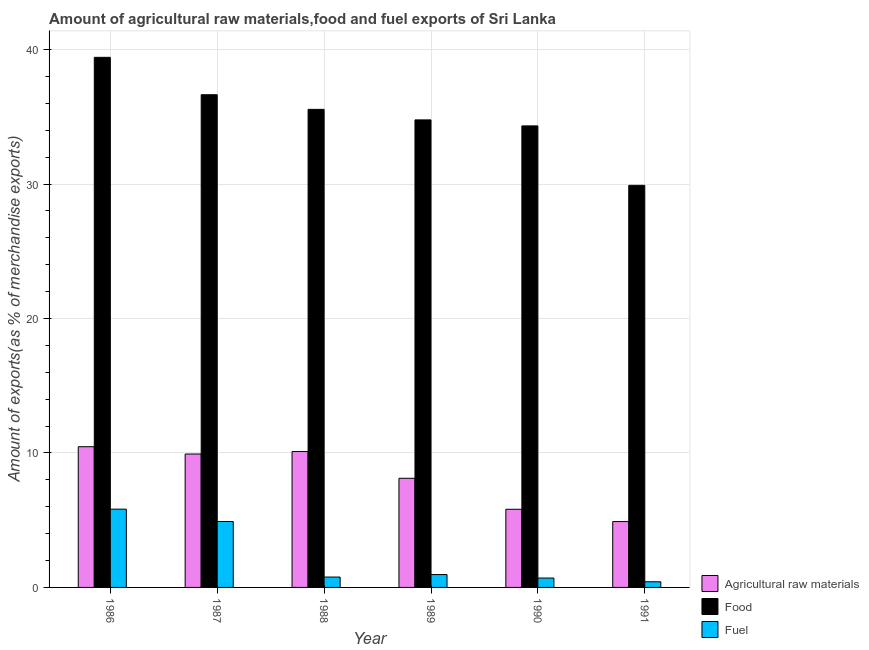Are the number of bars per tick equal to the number of legend labels?
Your answer should be compact. Yes. How many bars are there on the 4th tick from the right?
Provide a short and direct response. 3. What is the percentage of raw materials exports in 1991?
Offer a terse response. 4.9. Across all years, what is the maximum percentage of raw materials exports?
Your response must be concise. 10.47. Across all years, what is the minimum percentage of food exports?
Provide a succinct answer. 29.9. In which year was the percentage of raw materials exports maximum?
Your answer should be compact. 1986. What is the total percentage of food exports in the graph?
Give a very brief answer. 210.63. What is the difference between the percentage of raw materials exports in 1987 and that in 1991?
Your answer should be compact. 5.02. What is the difference between the percentage of food exports in 1988 and the percentage of raw materials exports in 1991?
Provide a short and direct response. 5.65. What is the average percentage of raw materials exports per year?
Make the answer very short. 8.22. In the year 1990, what is the difference between the percentage of fuel exports and percentage of raw materials exports?
Provide a short and direct response. 0. What is the ratio of the percentage of fuel exports in 1990 to that in 1991?
Your response must be concise. 1.66. What is the difference between the highest and the second highest percentage of food exports?
Your answer should be very brief. 2.78. What is the difference between the highest and the lowest percentage of fuel exports?
Provide a succinct answer. 5.4. In how many years, is the percentage of food exports greater than the average percentage of food exports taken over all years?
Ensure brevity in your answer.  3. Is the sum of the percentage of food exports in 1988 and 1991 greater than the maximum percentage of raw materials exports across all years?
Make the answer very short. Yes. What does the 1st bar from the left in 1987 represents?
Your answer should be compact. Agricultural raw materials. What does the 1st bar from the right in 1990 represents?
Ensure brevity in your answer.  Fuel. Are all the bars in the graph horizontal?
Your answer should be very brief. No. How many years are there in the graph?
Give a very brief answer. 6. Are the values on the major ticks of Y-axis written in scientific E-notation?
Your answer should be very brief. No. How are the legend labels stacked?
Offer a terse response. Vertical. What is the title of the graph?
Offer a terse response. Amount of agricultural raw materials,food and fuel exports of Sri Lanka. Does "Travel services" appear as one of the legend labels in the graph?
Keep it short and to the point. No. What is the label or title of the Y-axis?
Ensure brevity in your answer.  Amount of exports(as % of merchandise exports). What is the Amount of exports(as % of merchandise exports) of Agricultural raw materials in 1986?
Keep it short and to the point. 10.47. What is the Amount of exports(as % of merchandise exports) in Food in 1986?
Provide a short and direct response. 39.43. What is the Amount of exports(as % of merchandise exports) of Fuel in 1986?
Give a very brief answer. 5.82. What is the Amount of exports(as % of merchandise exports) of Agricultural raw materials in 1987?
Give a very brief answer. 9.92. What is the Amount of exports(as % of merchandise exports) in Food in 1987?
Your response must be concise. 36.64. What is the Amount of exports(as % of merchandise exports) in Fuel in 1987?
Make the answer very short. 4.9. What is the Amount of exports(as % of merchandise exports) of Agricultural raw materials in 1988?
Your answer should be very brief. 10.11. What is the Amount of exports(as % of merchandise exports) in Food in 1988?
Your response must be concise. 35.56. What is the Amount of exports(as % of merchandise exports) of Fuel in 1988?
Make the answer very short. 0.77. What is the Amount of exports(as % of merchandise exports) of Agricultural raw materials in 1989?
Provide a succinct answer. 8.12. What is the Amount of exports(as % of merchandise exports) in Food in 1989?
Offer a very short reply. 34.77. What is the Amount of exports(as % of merchandise exports) in Fuel in 1989?
Your response must be concise. 0.96. What is the Amount of exports(as % of merchandise exports) of Agricultural raw materials in 1990?
Your answer should be very brief. 5.81. What is the Amount of exports(as % of merchandise exports) in Food in 1990?
Offer a terse response. 34.33. What is the Amount of exports(as % of merchandise exports) in Fuel in 1990?
Your answer should be compact. 0.7. What is the Amount of exports(as % of merchandise exports) in Agricultural raw materials in 1991?
Ensure brevity in your answer.  4.9. What is the Amount of exports(as % of merchandise exports) in Food in 1991?
Your response must be concise. 29.9. What is the Amount of exports(as % of merchandise exports) of Fuel in 1991?
Keep it short and to the point. 0.42. Across all years, what is the maximum Amount of exports(as % of merchandise exports) in Agricultural raw materials?
Keep it short and to the point. 10.47. Across all years, what is the maximum Amount of exports(as % of merchandise exports) of Food?
Provide a short and direct response. 39.43. Across all years, what is the maximum Amount of exports(as % of merchandise exports) of Fuel?
Ensure brevity in your answer.  5.82. Across all years, what is the minimum Amount of exports(as % of merchandise exports) of Agricultural raw materials?
Your answer should be very brief. 4.9. Across all years, what is the minimum Amount of exports(as % of merchandise exports) in Food?
Your response must be concise. 29.9. Across all years, what is the minimum Amount of exports(as % of merchandise exports) of Fuel?
Provide a succinct answer. 0.42. What is the total Amount of exports(as % of merchandise exports) in Agricultural raw materials in the graph?
Provide a succinct answer. 49.32. What is the total Amount of exports(as % of merchandise exports) of Food in the graph?
Your answer should be compact. 210.63. What is the total Amount of exports(as % of merchandise exports) in Fuel in the graph?
Give a very brief answer. 13.57. What is the difference between the Amount of exports(as % of merchandise exports) in Agricultural raw materials in 1986 and that in 1987?
Provide a succinct answer. 0.54. What is the difference between the Amount of exports(as % of merchandise exports) in Food in 1986 and that in 1987?
Offer a terse response. 2.78. What is the difference between the Amount of exports(as % of merchandise exports) of Fuel in 1986 and that in 1987?
Offer a terse response. 0.92. What is the difference between the Amount of exports(as % of merchandise exports) of Agricultural raw materials in 1986 and that in 1988?
Offer a very short reply. 0.36. What is the difference between the Amount of exports(as % of merchandise exports) in Food in 1986 and that in 1988?
Your answer should be compact. 3.87. What is the difference between the Amount of exports(as % of merchandise exports) of Fuel in 1986 and that in 1988?
Offer a terse response. 5.05. What is the difference between the Amount of exports(as % of merchandise exports) in Agricultural raw materials in 1986 and that in 1989?
Ensure brevity in your answer.  2.35. What is the difference between the Amount of exports(as % of merchandise exports) of Food in 1986 and that in 1989?
Keep it short and to the point. 4.65. What is the difference between the Amount of exports(as % of merchandise exports) of Fuel in 1986 and that in 1989?
Offer a terse response. 4.87. What is the difference between the Amount of exports(as % of merchandise exports) of Agricultural raw materials in 1986 and that in 1990?
Your response must be concise. 4.65. What is the difference between the Amount of exports(as % of merchandise exports) of Food in 1986 and that in 1990?
Keep it short and to the point. 5.1. What is the difference between the Amount of exports(as % of merchandise exports) of Fuel in 1986 and that in 1990?
Your answer should be compact. 5.12. What is the difference between the Amount of exports(as % of merchandise exports) of Agricultural raw materials in 1986 and that in 1991?
Your answer should be very brief. 5.57. What is the difference between the Amount of exports(as % of merchandise exports) of Food in 1986 and that in 1991?
Make the answer very short. 9.52. What is the difference between the Amount of exports(as % of merchandise exports) in Fuel in 1986 and that in 1991?
Your response must be concise. 5.4. What is the difference between the Amount of exports(as % of merchandise exports) of Agricultural raw materials in 1987 and that in 1988?
Keep it short and to the point. -0.18. What is the difference between the Amount of exports(as % of merchandise exports) in Food in 1987 and that in 1988?
Provide a succinct answer. 1.09. What is the difference between the Amount of exports(as % of merchandise exports) in Fuel in 1987 and that in 1988?
Your answer should be compact. 4.13. What is the difference between the Amount of exports(as % of merchandise exports) in Agricultural raw materials in 1987 and that in 1989?
Ensure brevity in your answer.  1.8. What is the difference between the Amount of exports(as % of merchandise exports) in Food in 1987 and that in 1989?
Your answer should be compact. 1.87. What is the difference between the Amount of exports(as % of merchandise exports) in Fuel in 1987 and that in 1989?
Offer a terse response. 3.95. What is the difference between the Amount of exports(as % of merchandise exports) of Agricultural raw materials in 1987 and that in 1990?
Provide a succinct answer. 4.11. What is the difference between the Amount of exports(as % of merchandise exports) of Food in 1987 and that in 1990?
Keep it short and to the point. 2.32. What is the difference between the Amount of exports(as % of merchandise exports) of Fuel in 1987 and that in 1990?
Your answer should be very brief. 4.2. What is the difference between the Amount of exports(as % of merchandise exports) in Agricultural raw materials in 1987 and that in 1991?
Your answer should be very brief. 5.02. What is the difference between the Amount of exports(as % of merchandise exports) in Food in 1987 and that in 1991?
Your answer should be very brief. 6.74. What is the difference between the Amount of exports(as % of merchandise exports) of Fuel in 1987 and that in 1991?
Give a very brief answer. 4.48. What is the difference between the Amount of exports(as % of merchandise exports) of Agricultural raw materials in 1988 and that in 1989?
Your answer should be compact. 1.99. What is the difference between the Amount of exports(as % of merchandise exports) of Food in 1988 and that in 1989?
Keep it short and to the point. 0.78. What is the difference between the Amount of exports(as % of merchandise exports) in Fuel in 1988 and that in 1989?
Your answer should be very brief. -0.18. What is the difference between the Amount of exports(as % of merchandise exports) in Agricultural raw materials in 1988 and that in 1990?
Give a very brief answer. 4.29. What is the difference between the Amount of exports(as % of merchandise exports) of Food in 1988 and that in 1990?
Offer a terse response. 1.23. What is the difference between the Amount of exports(as % of merchandise exports) in Fuel in 1988 and that in 1990?
Provide a succinct answer. 0.07. What is the difference between the Amount of exports(as % of merchandise exports) in Agricultural raw materials in 1988 and that in 1991?
Make the answer very short. 5.21. What is the difference between the Amount of exports(as % of merchandise exports) of Food in 1988 and that in 1991?
Offer a terse response. 5.65. What is the difference between the Amount of exports(as % of merchandise exports) of Fuel in 1988 and that in 1991?
Offer a terse response. 0.35. What is the difference between the Amount of exports(as % of merchandise exports) in Agricultural raw materials in 1989 and that in 1990?
Ensure brevity in your answer.  2.3. What is the difference between the Amount of exports(as % of merchandise exports) of Food in 1989 and that in 1990?
Give a very brief answer. 0.45. What is the difference between the Amount of exports(as % of merchandise exports) of Fuel in 1989 and that in 1990?
Your answer should be compact. 0.26. What is the difference between the Amount of exports(as % of merchandise exports) of Agricultural raw materials in 1989 and that in 1991?
Your answer should be compact. 3.22. What is the difference between the Amount of exports(as % of merchandise exports) of Food in 1989 and that in 1991?
Offer a terse response. 4.87. What is the difference between the Amount of exports(as % of merchandise exports) in Fuel in 1989 and that in 1991?
Your answer should be very brief. 0.54. What is the difference between the Amount of exports(as % of merchandise exports) of Agricultural raw materials in 1990 and that in 1991?
Your response must be concise. 0.91. What is the difference between the Amount of exports(as % of merchandise exports) in Food in 1990 and that in 1991?
Provide a short and direct response. 4.42. What is the difference between the Amount of exports(as % of merchandise exports) of Fuel in 1990 and that in 1991?
Your response must be concise. 0.28. What is the difference between the Amount of exports(as % of merchandise exports) in Agricultural raw materials in 1986 and the Amount of exports(as % of merchandise exports) in Food in 1987?
Give a very brief answer. -26.18. What is the difference between the Amount of exports(as % of merchandise exports) of Agricultural raw materials in 1986 and the Amount of exports(as % of merchandise exports) of Fuel in 1987?
Offer a terse response. 5.56. What is the difference between the Amount of exports(as % of merchandise exports) in Food in 1986 and the Amount of exports(as % of merchandise exports) in Fuel in 1987?
Provide a succinct answer. 34.52. What is the difference between the Amount of exports(as % of merchandise exports) of Agricultural raw materials in 1986 and the Amount of exports(as % of merchandise exports) of Food in 1988?
Provide a succinct answer. -25.09. What is the difference between the Amount of exports(as % of merchandise exports) in Agricultural raw materials in 1986 and the Amount of exports(as % of merchandise exports) in Fuel in 1988?
Keep it short and to the point. 9.7. What is the difference between the Amount of exports(as % of merchandise exports) of Food in 1986 and the Amount of exports(as % of merchandise exports) of Fuel in 1988?
Offer a terse response. 38.66. What is the difference between the Amount of exports(as % of merchandise exports) of Agricultural raw materials in 1986 and the Amount of exports(as % of merchandise exports) of Food in 1989?
Offer a very short reply. -24.31. What is the difference between the Amount of exports(as % of merchandise exports) in Agricultural raw materials in 1986 and the Amount of exports(as % of merchandise exports) in Fuel in 1989?
Provide a succinct answer. 9.51. What is the difference between the Amount of exports(as % of merchandise exports) in Food in 1986 and the Amount of exports(as % of merchandise exports) in Fuel in 1989?
Your response must be concise. 38.47. What is the difference between the Amount of exports(as % of merchandise exports) in Agricultural raw materials in 1986 and the Amount of exports(as % of merchandise exports) in Food in 1990?
Offer a very short reply. -23.86. What is the difference between the Amount of exports(as % of merchandise exports) of Agricultural raw materials in 1986 and the Amount of exports(as % of merchandise exports) of Fuel in 1990?
Your answer should be very brief. 9.77. What is the difference between the Amount of exports(as % of merchandise exports) in Food in 1986 and the Amount of exports(as % of merchandise exports) in Fuel in 1990?
Your response must be concise. 38.73. What is the difference between the Amount of exports(as % of merchandise exports) of Agricultural raw materials in 1986 and the Amount of exports(as % of merchandise exports) of Food in 1991?
Keep it short and to the point. -19.44. What is the difference between the Amount of exports(as % of merchandise exports) of Agricultural raw materials in 1986 and the Amount of exports(as % of merchandise exports) of Fuel in 1991?
Give a very brief answer. 10.05. What is the difference between the Amount of exports(as % of merchandise exports) in Food in 1986 and the Amount of exports(as % of merchandise exports) in Fuel in 1991?
Provide a short and direct response. 39.01. What is the difference between the Amount of exports(as % of merchandise exports) in Agricultural raw materials in 1987 and the Amount of exports(as % of merchandise exports) in Food in 1988?
Offer a very short reply. -25.63. What is the difference between the Amount of exports(as % of merchandise exports) of Agricultural raw materials in 1987 and the Amount of exports(as % of merchandise exports) of Fuel in 1988?
Give a very brief answer. 9.15. What is the difference between the Amount of exports(as % of merchandise exports) of Food in 1987 and the Amount of exports(as % of merchandise exports) of Fuel in 1988?
Provide a short and direct response. 35.87. What is the difference between the Amount of exports(as % of merchandise exports) in Agricultural raw materials in 1987 and the Amount of exports(as % of merchandise exports) in Food in 1989?
Keep it short and to the point. -24.85. What is the difference between the Amount of exports(as % of merchandise exports) in Agricultural raw materials in 1987 and the Amount of exports(as % of merchandise exports) in Fuel in 1989?
Provide a succinct answer. 8.97. What is the difference between the Amount of exports(as % of merchandise exports) of Food in 1987 and the Amount of exports(as % of merchandise exports) of Fuel in 1989?
Your response must be concise. 35.69. What is the difference between the Amount of exports(as % of merchandise exports) of Agricultural raw materials in 1987 and the Amount of exports(as % of merchandise exports) of Food in 1990?
Give a very brief answer. -24.4. What is the difference between the Amount of exports(as % of merchandise exports) of Agricultural raw materials in 1987 and the Amount of exports(as % of merchandise exports) of Fuel in 1990?
Your answer should be very brief. 9.22. What is the difference between the Amount of exports(as % of merchandise exports) of Food in 1987 and the Amount of exports(as % of merchandise exports) of Fuel in 1990?
Keep it short and to the point. 35.95. What is the difference between the Amount of exports(as % of merchandise exports) of Agricultural raw materials in 1987 and the Amount of exports(as % of merchandise exports) of Food in 1991?
Your answer should be very brief. -19.98. What is the difference between the Amount of exports(as % of merchandise exports) of Agricultural raw materials in 1987 and the Amount of exports(as % of merchandise exports) of Fuel in 1991?
Offer a very short reply. 9.5. What is the difference between the Amount of exports(as % of merchandise exports) of Food in 1987 and the Amount of exports(as % of merchandise exports) of Fuel in 1991?
Keep it short and to the point. 36.22. What is the difference between the Amount of exports(as % of merchandise exports) in Agricultural raw materials in 1988 and the Amount of exports(as % of merchandise exports) in Food in 1989?
Your response must be concise. -24.67. What is the difference between the Amount of exports(as % of merchandise exports) in Agricultural raw materials in 1988 and the Amount of exports(as % of merchandise exports) in Fuel in 1989?
Offer a very short reply. 9.15. What is the difference between the Amount of exports(as % of merchandise exports) of Food in 1988 and the Amount of exports(as % of merchandise exports) of Fuel in 1989?
Ensure brevity in your answer.  34.6. What is the difference between the Amount of exports(as % of merchandise exports) in Agricultural raw materials in 1988 and the Amount of exports(as % of merchandise exports) in Food in 1990?
Keep it short and to the point. -24.22. What is the difference between the Amount of exports(as % of merchandise exports) of Agricultural raw materials in 1988 and the Amount of exports(as % of merchandise exports) of Fuel in 1990?
Give a very brief answer. 9.41. What is the difference between the Amount of exports(as % of merchandise exports) in Food in 1988 and the Amount of exports(as % of merchandise exports) in Fuel in 1990?
Your response must be concise. 34.86. What is the difference between the Amount of exports(as % of merchandise exports) in Agricultural raw materials in 1988 and the Amount of exports(as % of merchandise exports) in Food in 1991?
Keep it short and to the point. -19.8. What is the difference between the Amount of exports(as % of merchandise exports) of Agricultural raw materials in 1988 and the Amount of exports(as % of merchandise exports) of Fuel in 1991?
Make the answer very short. 9.69. What is the difference between the Amount of exports(as % of merchandise exports) in Food in 1988 and the Amount of exports(as % of merchandise exports) in Fuel in 1991?
Make the answer very short. 35.13. What is the difference between the Amount of exports(as % of merchandise exports) of Agricultural raw materials in 1989 and the Amount of exports(as % of merchandise exports) of Food in 1990?
Offer a terse response. -26.21. What is the difference between the Amount of exports(as % of merchandise exports) in Agricultural raw materials in 1989 and the Amount of exports(as % of merchandise exports) in Fuel in 1990?
Provide a short and direct response. 7.42. What is the difference between the Amount of exports(as % of merchandise exports) of Food in 1989 and the Amount of exports(as % of merchandise exports) of Fuel in 1990?
Your response must be concise. 34.07. What is the difference between the Amount of exports(as % of merchandise exports) of Agricultural raw materials in 1989 and the Amount of exports(as % of merchandise exports) of Food in 1991?
Provide a succinct answer. -21.79. What is the difference between the Amount of exports(as % of merchandise exports) of Agricultural raw materials in 1989 and the Amount of exports(as % of merchandise exports) of Fuel in 1991?
Make the answer very short. 7.7. What is the difference between the Amount of exports(as % of merchandise exports) in Food in 1989 and the Amount of exports(as % of merchandise exports) in Fuel in 1991?
Keep it short and to the point. 34.35. What is the difference between the Amount of exports(as % of merchandise exports) of Agricultural raw materials in 1990 and the Amount of exports(as % of merchandise exports) of Food in 1991?
Your answer should be compact. -24.09. What is the difference between the Amount of exports(as % of merchandise exports) of Agricultural raw materials in 1990 and the Amount of exports(as % of merchandise exports) of Fuel in 1991?
Make the answer very short. 5.39. What is the difference between the Amount of exports(as % of merchandise exports) in Food in 1990 and the Amount of exports(as % of merchandise exports) in Fuel in 1991?
Keep it short and to the point. 33.91. What is the average Amount of exports(as % of merchandise exports) in Agricultural raw materials per year?
Make the answer very short. 8.22. What is the average Amount of exports(as % of merchandise exports) in Food per year?
Provide a short and direct response. 35.1. What is the average Amount of exports(as % of merchandise exports) of Fuel per year?
Keep it short and to the point. 2.26. In the year 1986, what is the difference between the Amount of exports(as % of merchandise exports) in Agricultural raw materials and Amount of exports(as % of merchandise exports) in Food?
Your response must be concise. -28.96. In the year 1986, what is the difference between the Amount of exports(as % of merchandise exports) in Agricultural raw materials and Amount of exports(as % of merchandise exports) in Fuel?
Ensure brevity in your answer.  4.64. In the year 1986, what is the difference between the Amount of exports(as % of merchandise exports) in Food and Amount of exports(as % of merchandise exports) in Fuel?
Your answer should be very brief. 33.6. In the year 1987, what is the difference between the Amount of exports(as % of merchandise exports) of Agricultural raw materials and Amount of exports(as % of merchandise exports) of Food?
Keep it short and to the point. -26.72. In the year 1987, what is the difference between the Amount of exports(as % of merchandise exports) in Agricultural raw materials and Amount of exports(as % of merchandise exports) in Fuel?
Keep it short and to the point. 5.02. In the year 1987, what is the difference between the Amount of exports(as % of merchandise exports) of Food and Amount of exports(as % of merchandise exports) of Fuel?
Provide a succinct answer. 31.74. In the year 1988, what is the difference between the Amount of exports(as % of merchandise exports) of Agricultural raw materials and Amount of exports(as % of merchandise exports) of Food?
Offer a terse response. -25.45. In the year 1988, what is the difference between the Amount of exports(as % of merchandise exports) in Agricultural raw materials and Amount of exports(as % of merchandise exports) in Fuel?
Offer a very short reply. 9.34. In the year 1988, what is the difference between the Amount of exports(as % of merchandise exports) in Food and Amount of exports(as % of merchandise exports) in Fuel?
Ensure brevity in your answer.  34.78. In the year 1989, what is the difference between the Amount of exports(as % of merchandise exports) in Agricultural raw materials and Amount of exports(as % of merchandise exports) in Food?
Provide a succinct answer. -26.66. In the year 1989, what is the difference between the Amount of exports(as % of merchandise exports) in Agricultural raw materials and Amount of exports(as % of merchandise exports) in Fuel?
Keep it short and to the point. 7.16. In the year 1989, what is the difference between the Amount of exports(as % of merchandise exports) in Food and Amount of exports(as % of merchandise exports) in Fuel?
Your answer should be compact. 33.82. In the year 1990, what is the difference between the Amount of exports(as % of merchandise exports) in Agricultural raw materials and Amount of exports(as % of merchandise exports) in Food?
Your answer should be very brief. -28.51. In the year 1990, what is the difference between the Amount of exports(as % of merchandise exports) of Agricultural raw materials and Amount of exports(as % of merchandise exports) of Fuel?
Offer a terse response. 5.11. In the year 1990, what is the difference between the Amount of exports(as % of merchandise exports) in Food and Amount of exports(as % of merchandise exports) in Fuel?
Keep it short and to the point. 33.63. In the year 1991, what is the difference between the Amount of exports(as % of merchandise exports) of Agricultural raw materials and Amount of exports(as % of merchandise exports) of Food?
Your answer should be compact. -25. In the year 1991, what is the difference between the Amount of exports(as % of merchandise exports) of Agricultural raw materials and Amount of exports(as % of merchandise exports) of Fuel?
Provide a short and direct response. 4.48. In the year 1991, what is the difference between the Amount of exports(as % of merchandise exports) of Food and Amount of exports(as % of merchandise exports) of Fuel?
Provide a succinct answer. 29.48. What is the ratio of the Amount of exports(as % of merchandise exports) in Agricultural raw materials in 1986 to that in 1987?
Your answer should be very brief. 1.05. What is the ratio of the Amount of exports(as % of merchandise exports) in Food in 1986 to that in 1987?
Offer a very short reply. 1.08. What is the ratio of the Amount of exports(as % of merchandise exports) in Fuel in 1986 to that in 1987?
Offer a very short reply. 1.19. What is the ratio of the Amount of exports(as % of merchandise exports) in Agricultural raw materials in 1986 to that in 1988?
Provide a short and direct response. 1.04. What is the ratio of the Amount of exports(as % of merchandise exports) of Food in 1986 to that in 1988?
Your answer should be compact. 1.11. What is the ratio of the Amount of exports(as % of merchandise exports) in Fuel in 1986 to that in 1988?
Your answer should be very brief. 7.55. What is the ratio of the Amount of exports(as % of merchandise exports) of Agricultural raw materials in 1986 to that in 1989?
Your answer should be very brief. 1.29. What is the ratio of the Amount of exports(as % of merchandise exports) in Food in 1986 to that in 1989?
Give a very brief answer. 1.13. What is the ratio of the Amount of exports(as % of merchandise exports) in Fuel in 1986 to that in 1989?
Ensure brevity in your answer.  6.09. What is the ratio of the Amount of exports(as % of merchandise exports) in Agricultural raw materials in 1986 to that in 1990?
Provide a succinct answer. 1.8. What is the ratio of the Amount of exports(as % of merchandise exports) of Food in 1986 to that in 1990?
Your answer should be very brief. 1.15. What is the ratio of the Amount of exports(as % of merchandise exports) in Fuel in 1986 to that in 1990?
Offer a very short reply. 8.33. What is the ratio of the Amount of exports(as % of merchandise exports) in Agricultural raw materials in 1986 to that in 1991?
Provide a short and direct response. 2.14. What is the ratio of the Amount of exports(as % of merchandise exports) of Food in 1986 to that in 1991?
Give a very brief answer. 1.32. What is the ratio of the Amount of exports(as % of merchandise exports) in Fuel in 1986 to that in 1991?
Provide a short and direct response. 13.83. What is the ratio of the Amount of exports(as % of merchandise exports) of Agricultural raw materials in 1987 to that in 1988?
Give a very brief answer. 0.98. What is the ratio of the Amount of exports(as % of merchandise exports) of Food in 1987 to that in 1988?
Ensure brevity in your answer.  1.03. What is the ratio of the Amount of exports(as % of merchandise exports) in Fuel in 1987 to that in 1988?
Your answer should be compact. 6.36. What is the ratio of the Amount of exports(as % of merchandise exports) of Agricultural raw materials in 1987 to that in 1989?
Keep it short and to the point. 1.22. What is the ratio of the Amount of exports(as % of merchandise exports) of Food in 1987 to that in 1989?
Your response must be concise. 1.05. What is the ratio of the Amount of exports(as % of merchandise exports) of Fuel in 1987 to that in 1989?
Keep it short and to the point. 5.13. What is the ratio of the Amount of exports(as % of merchandise exports) of Agricultural raw materials in 1987 to that in 1990?
Make the answer very short. 1.71. What is the ratio of the Amount of exports(as % of merchandise exports) in Food in 1987 to that in 1990?
Give a very brief answer. 1.07. What is the ratio of the Amount of exports(as % of merchandise exports) in Fuel in 1987 to that in 1990?
Your answer should be very brief. 7.02. What is the ratio of the Amount of exports(as % of merchandise exports) in Agricultural raw materials in 1987 to that in 1991?
Keep it short and to the point. 2.02. What is the ratio of the Amount of exports(as % of merchandise exports) of Food in 1987 to that in 1991?
Your response must be concise. 1.23. What is the ratio of the Amount of exports(as % of merchandise exports) of Fuel in 1987 to that in 1991?
Ensure brevity in your answer.  11.65. What is the ratio of the Amount of exports(as % of merchandise exports) in Agricultural raw materials in 1988 to that in 1989?
Make the answer very short. 1.25. What is the ratio of the Amount of exports(as % of merchandise exports) of Food in 1988 to that in 1989?
Your response must be concise. 1.02. What is the ratio of the Amount of exports(as % of merchandise exports) of Fuel in 1988 to that in 1989?
Offer a terse response. 0.81. What is the ratio of the Amount of exports(as % of merchandise exports) of Agricultural raw materials in 1988 to that in 1990?
Make the answer very short. 1.74. What is the ratio of the Amount of exports(as % of merchandise exports) of Food in 1988 to that in 1990?
Give a very brief answer. 1.04. What is the ratio of the Amount of exports(as % of merchandise exports) of Fuel in 1988 to that in 1990?
Give a very brief answer. 1.1. What is the ratio of the Amount of exports(as % of merchandise exports) of Agricultural raw materials in 1988 to that in 1991?
Ensure brevity in your answer.  2.06. What is the ratio of the Amount of exports(as % of merchandise exports) in Food in 1988 to that in 1991?
Your answer should be very brief. 1.19. What is the ratio of the Amount of exports(as % of merchandise exports) of Fuel in 1988 to that in 1991?
Keep it short and to the point. 1.83. What is the ratio of the Amount of exports(as % of merchandise exports) in Agricultural raw materials in 1989 to that in 1990?
Give a very brief answer. 1.4. What is the ratio of the Amount of exports(as % of merchandise exports) in Fuel in 1989 to that in 1990?
Your answer should be very brief. 1.37. What is the ratio of the Amount of exports(as % of merchandise exports) of Agricultural raw materials in 1989 to that in 1991?
Give a very brief answer. 1.66. What is the ratio of the Amount of exports(as % of merchandise exports) in Food in 1989 to that in 1991?
Your answer should be very brief. 1.16. What is the ratio of the Amount of exports(as % of merchandise exports) in Fuel in 1989 to that in 1991?
Give a very brief answer. 2.27. What is the ratio of the Amount of exports(as % of merchandise exports) in Agricultural raw materials in 1990 to that in 1991?
Provide a short and direct response. 1.19. What is the ratio of the Amount of exports(as % of merchandise exports) of Food in 1990 to that in 1991?
Your answer should be compact. 1.15. What is the ratio of the Amount of exports(as % of merchandise exports) in Fuel in 1990 to that in 1991?
Give a very brief answer. 1.66. What is the difference between the highest and the second highest Amount of exports(as % of merchandise exports) of Agricultural raw materials?
Your answer should be compact. 0.36. What is the difference between the highest and the second highest Amount of exports(as % of merchandise exports) in Food?
Give a very brief answer. 2.78. What is the difference between the highest and the second highest Amount of exports(as % of merchandise exports) of Fuel?
Provide a short and direct response. 0.92. What is the difference between the highest and the lowest Amount of exports(as % of merchandise exports) in Agricultural raw materials?
Offer a terse response. 5.57. What is the difference between the highest and the lowest Amount of exports(as % of merchandise exports) of Food?
Your response must be concise. 9.52. What is the difference between the highest and the lowest Amount of exports(as % of merchandise exports) of Fuel?
Provide a succinct answer. 5.4. 